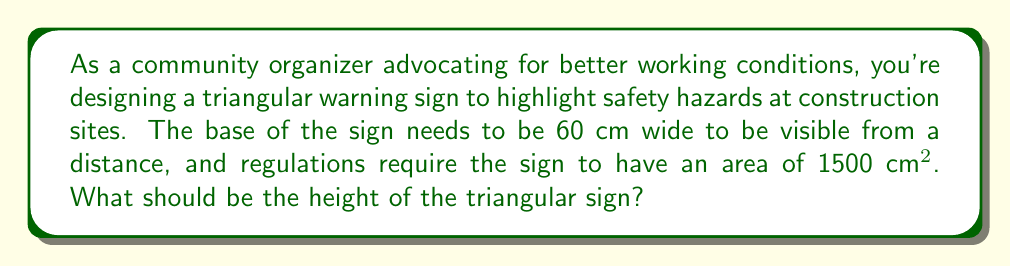Can you answer this question? Let's approach this step-by-step:

1) The formula for the area of a triangle is:

   $$A = \frac{1}{2} \times b \times h$$

   Where $A$ is the area, $b$ is the base, and $h$ is the height.

2) We're given that:
   - The area $A = 1500$ cm²
   - The base $b = 60$ cm

3) Let's substitute these values into the formula:

   $$1500 = \frac{1}{2} \times 60 \times h$$

4) Now, let's solve for $h$:

   $$1500 = 30h$$

   $$h = \frac{1500}{30}$$

   $$h = 50$$

5) Therefore, the height of the triangular sign should be 50 cm.

[asy]
unitsize(1cm);
pair A = (0,0), B = (6,0), C = (3,5);
draw(A--B--C--A);
label("60 cm", (3,-0.3));
label("50 cm", (6.3,2.5));
label("1500 cm²", (3,1.5));
[/asy]

This height will ensure the sign meets the area requirements while maintaining the specified base width, making it effective for warning workers about potential hazards.
Answer: The height of the triangular warning sign should be 50 cm. 